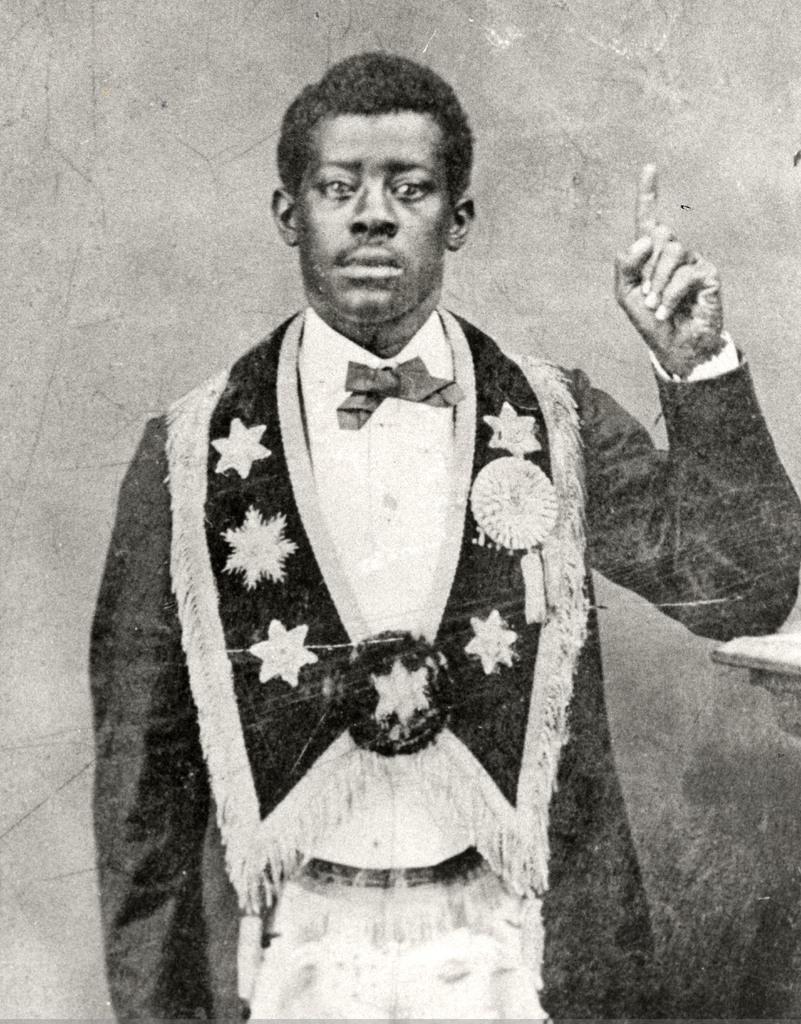In one or two sentences, can you explain what this image depicts? This is a black and white image. In this image we can see a person. In the background of the image there is wall. 